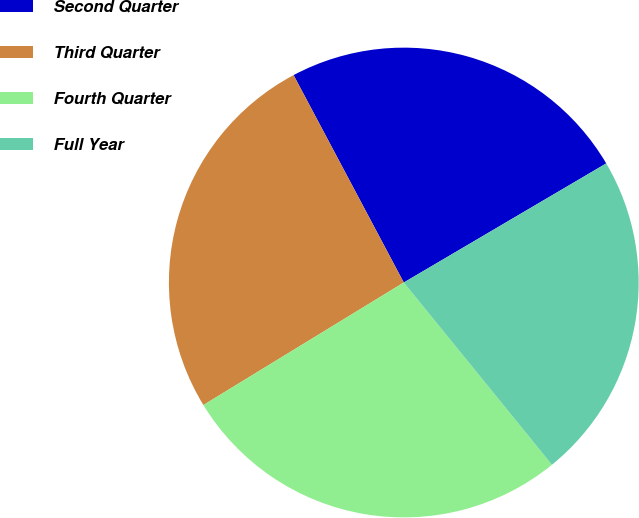<chart> <loc_0><loc_0><loc_500><loc_500><pie_chart><fcel>Second Quarter<fcel>Third Quarter<fcel>Fourth Quarter<fcel>Full Year<nl><fcel>24.31%<fcel>25.96%<fcel>27.13%<fcel>22.6%<nl></chart> 